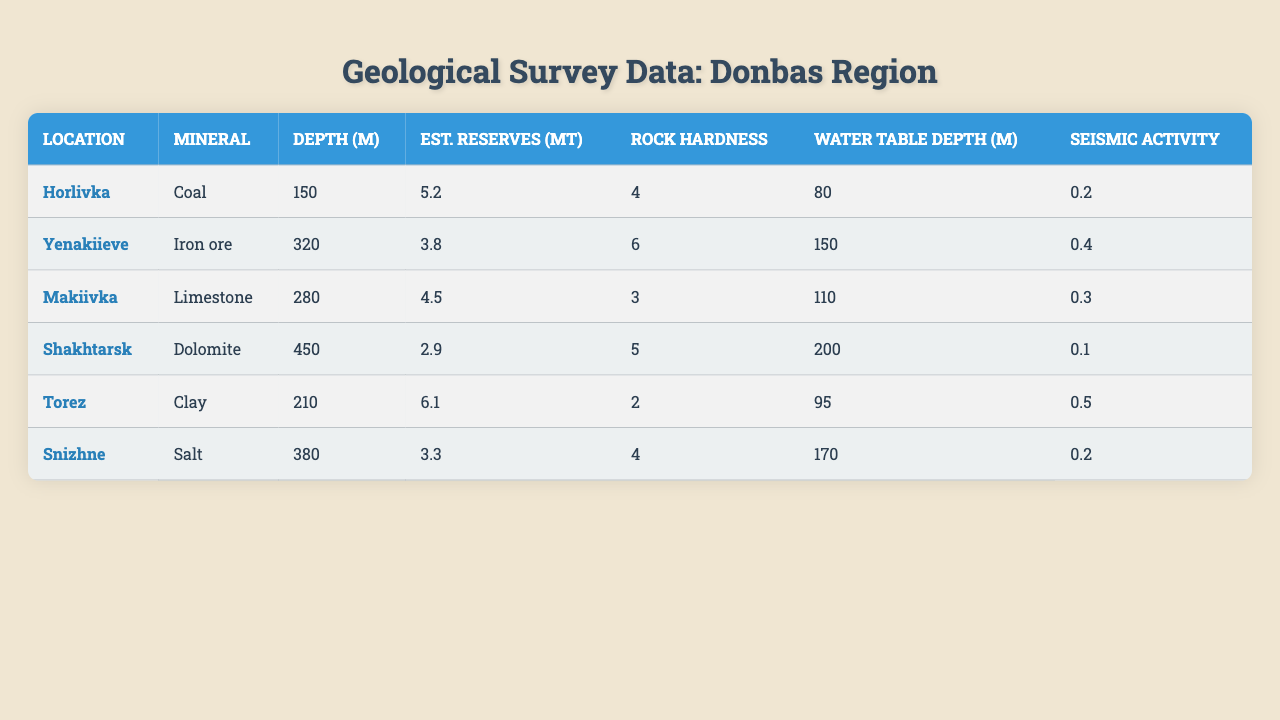What is the mineral found in Yenakiieve? According to the table, the mineral corresponding to the location Yenakiieve is Iron ore.
Answer: Iron ore Which location has the highest estimated reserves? The Table shows that Torez has the highest estimated reserves at 6.1 million tons.
Answer: Torez What is the depth of mining in Shakhtarsk? The table lists the mining depth in Shakhtarsk as 450 meters.
Answer: 450 meters Which location has the lowest rock hardness? By checking the rock hardness data, Snizhne has the lowest rock hardness value of 2.
Answer: Snizhne What is the average depth of all locations? The depths are 150, 320, 280, 450, 210, and 380 meters. Summing them gives 1790 meters, and dividing by 6 locations gives an average depth of 298.33 meters.
Answer: 298.33 meters Is the seismic activity in Makiivka higher than in Torez? The seismic activity in Makiivka is 0.3, while in Torez it is 0.5. Since 0.3 is less than 0.5, the statement is false.
Answer: No What are the estimated reserves of mineral from the location with the deepest mining? The deepest mining is in Shakhtarsk at 450 meters, where the estimated reserves are 2.9 million tons.
Answer: 2.9 million tons Which two locations have a water table depth higher than 150 meters? By looking through the water table depth, only Shakhtarsk (200 meters) and Snizhne (170 meters) have depths above 150 meters.
Answer: Shakhtarsk and Snizhne What is the total estimated reserves of all locations? Summing the estimated reserves: 5.2 + 3.8 + 4.5 + 2.9 + 6.1 + 3.3 = 25.8 million tons.
Answer: 25.8 million tons How many locations have a rock hardness equal to or greater than 5? The locations are Shakhtarsk (5), Yenakiieve (6), and Makiivka (3). Only Yenakiieve and Shakhtarsk have hardness of 5 or more, so that makes 2 locations.
Answer: 2 locations 